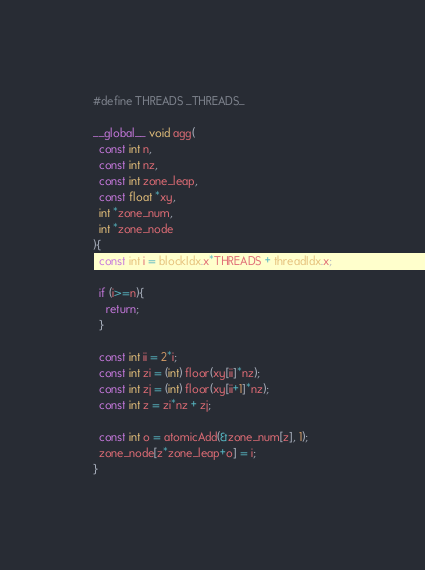<code> <loc_0><loc_0><loc_500><loc_500><_Cuda_>#define THREADS _THREADS_

__global__ void agg(
  const int n,
  const int nz,
  const int zone_leap,
  const float *xy,
  int *zone_num,
  int *zone_node
){
  const int i = blockIdx.x*THREADS + threadIdx.x;

  if (i>=n){
    return;
  }

  const int ii = 2*i;
  const int zi = (int) floor(xy[ii]*nz);
  const int zj = (int) floor(xy[ii+1]*nz);
  const int z = zi*nz + zj;

  const int o = atomicAdd(&zone_num[z], 1);
  zone_node[z*zone_leap+o] = i;
}

</code> 